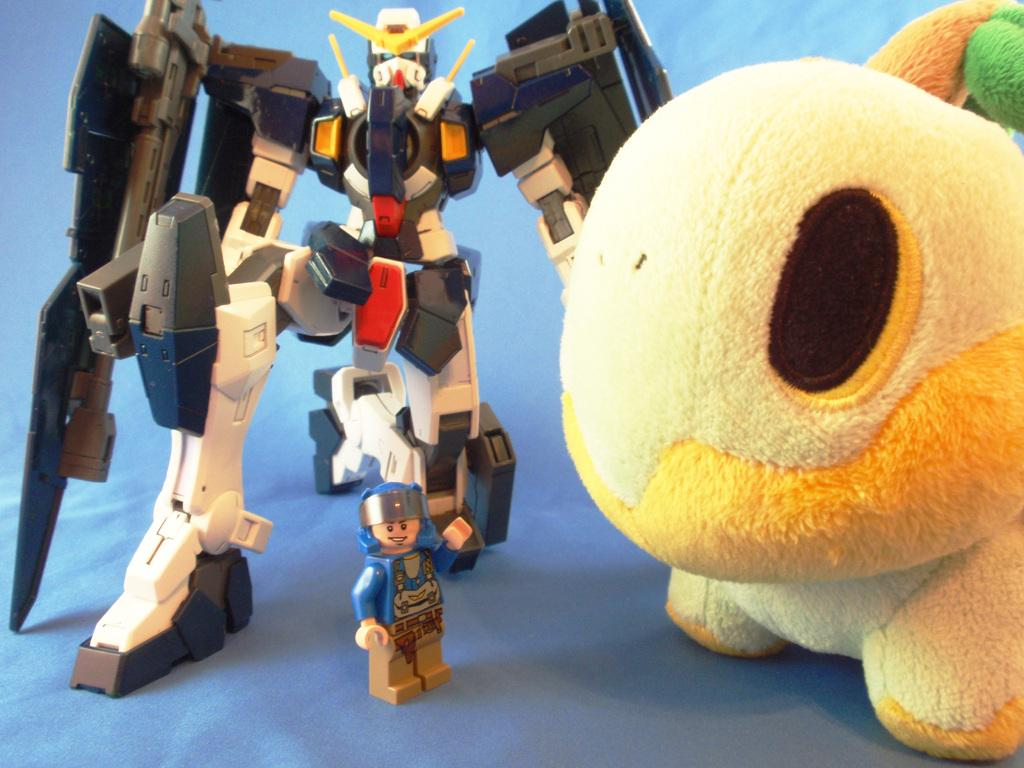What types of statues are present in the image? There is a robot statue and a human statue in the image. Where are the statues located? Both statues are on a table in the image. What other object can be seen on the table? There is a soft toy on the table. What type of copper material is used to create the curtain in the image? There is no curtain present in the image, and no mention of copper material. 